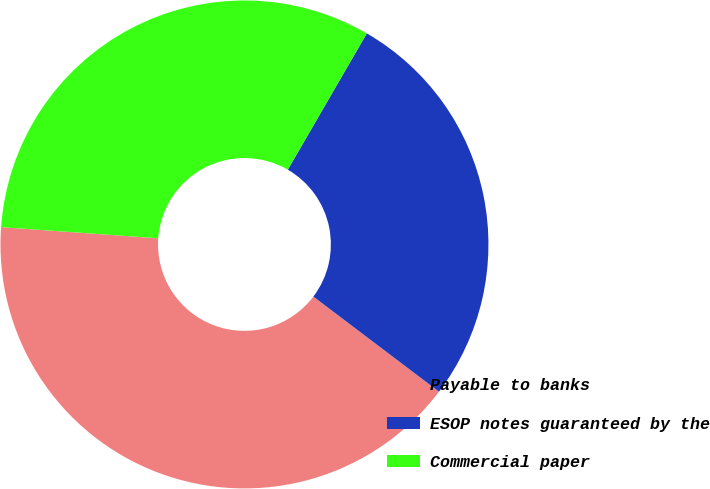Convert chart to OTSL. <chart><loc_0><loc_0><loc_500><loc_500><pie_chart><fcel>Payable to banks<fcel>ESOP notes guaranteed by the<fcel>Commercial paper<nl><fcel>40.82%<fcel>26.95%<fcel>32.23%<nl></chart> 